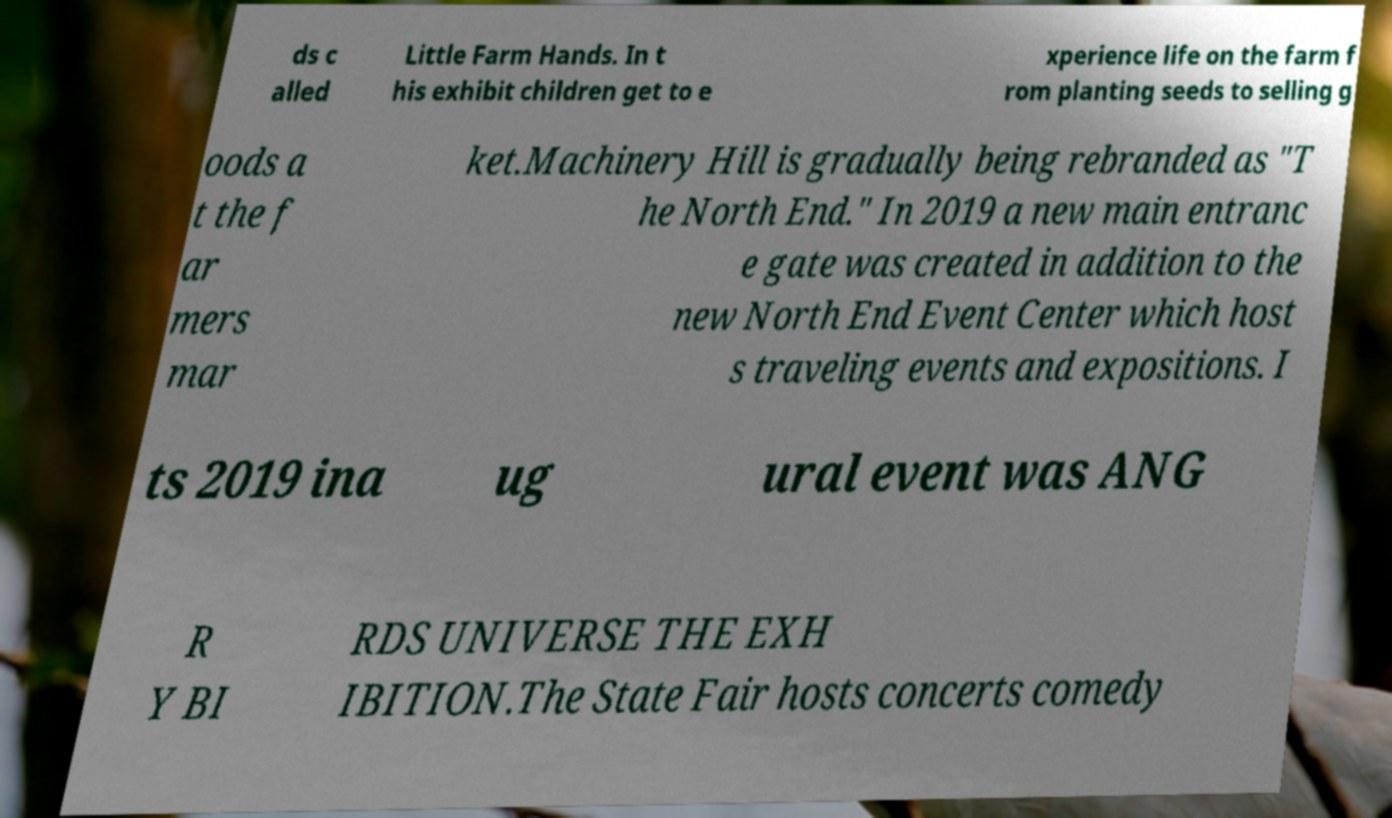Can you read and provide the text displayed in the image?This photo seems to have some interesting text. Can you extract and type it out for me? ds c alled Little Farm Hands. In t his exhibit children get to e xperience life on the farm f rom planting seeds to selling g oods a t the f ar mers mar ket.Machinery Hill is gradually being rebranded as "T he North End." In 2019 a new main entranc e gate was created in addition to the new North End Event Center which host s traveling events and expositions. I ts 2019 ina ug ural event was ANG R Y BI RDS UNIVERSE THE EXH IBITION.The State Fair hosts concerts comedy 